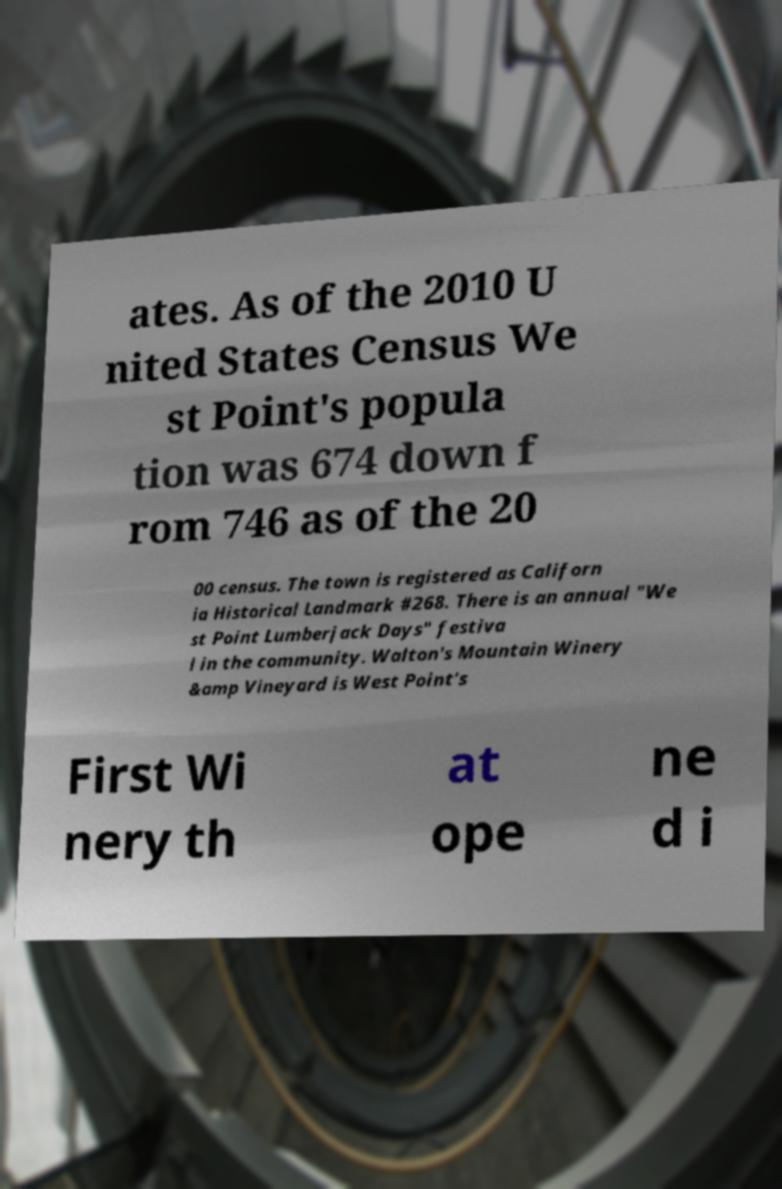I need the written content from this picture converted into text. Can you do that? ates. As of the 2010 U nited States Census We st Point's popula tion was 674 down f rom 746 as of the 20 00 census. The town is registered as Californ ia Historical Landmark #268. There is an annual "We st Point Lumberjack Days" festiva l in the community. Walton's Mountain Winery &amp Vineyard is West Point's First Wi nery th at ope ne d i 